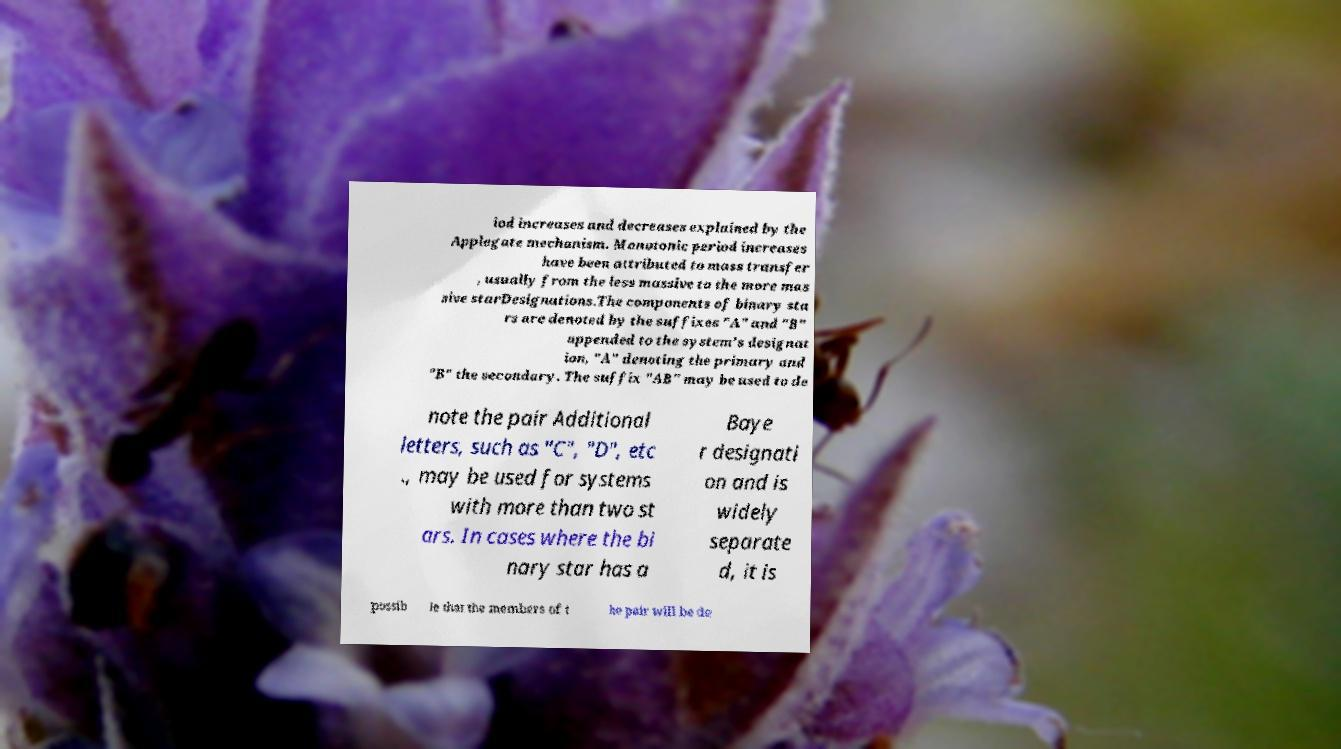I need the written content from this picture converted into text. Can you do that? iod increases and decreases explained by the Applegate mechanism. Monotonic period increases have been attributed to mass transfer , usually from the less massive to the more mas sive starDesignations.The components of binary sta rs are denoted by the suffixes "A" and "B" appended to the system's designat ion, "A" denoting the primary and "B" the secondary. The suffix "AB" may be used to de note the pair Additional letters, such as "C", "D", etc ., may be used for systems with more than two st ars. In cases where the bi nary star has a Baye r designati on and is widely separate d, it is possib le that the members of t he pair will be de 